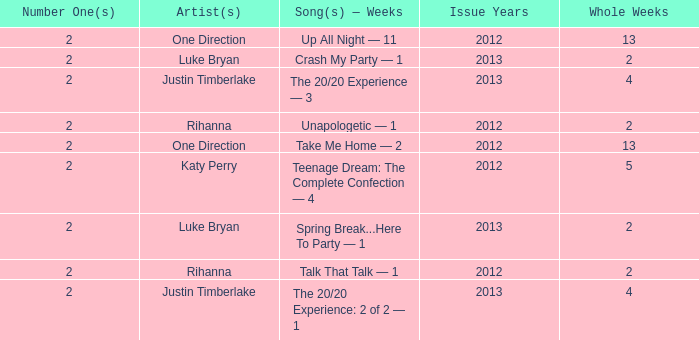What is the longest number of weeks any 1 song was at number #1? 13.0. 